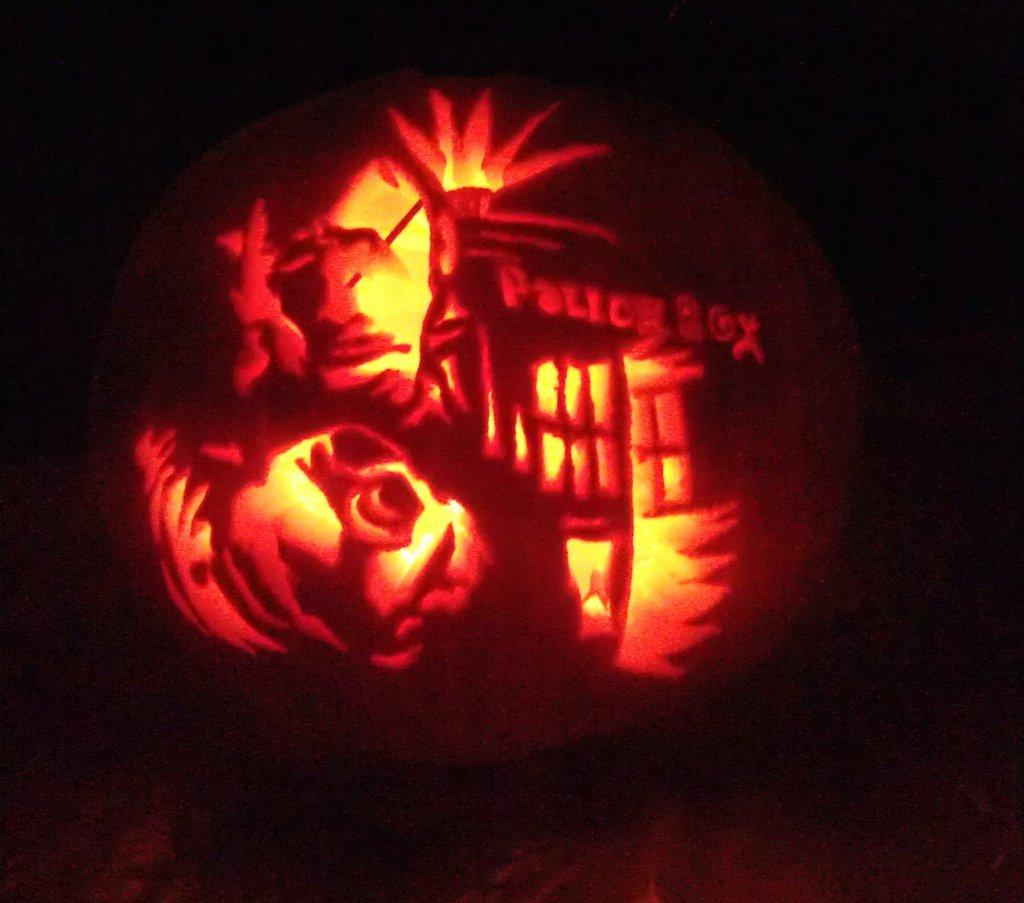What is the main object in the image? There is a carved pumpkin in the image. What is inside the pumpkin? There is a light inside the pumpkin. What color is the background of the image? The background of the image is black. What type of flame can be seen coming from the wire in the image? There is no wire or flame present in the image; it features a carved pumpkin with a light inside. 